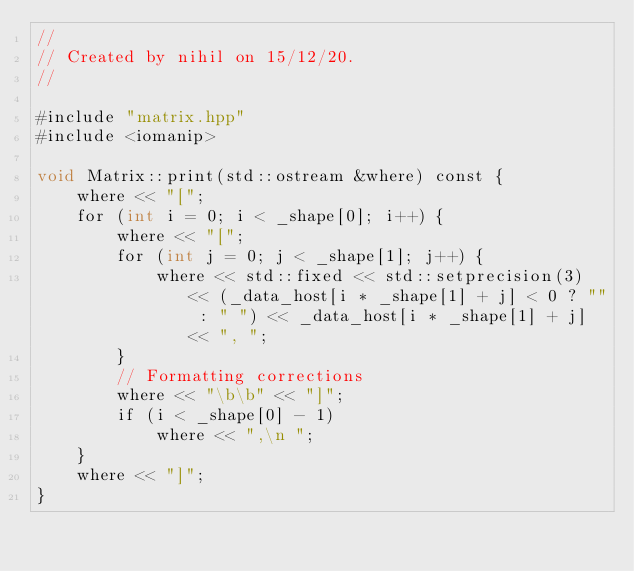<code> <loc_0><loc_0><loc_500><loc_500><_Cuda_>//
// Created by nihil on 15/12/20.
//

#include "matrix.hpp"
#include <iomanip>

void Matrix::print(std::ostream &where) const {
    where << "[";
    for (int i = 0; i < _shape[0]; i++) {
        where << "[";
        for (int j = 0; j < _shape[1]; j++) {
            where << std::fixed << std::setprecision(3) << (_data_host[i * _shape[1] + j] < 0 ? "" : " ") << _data_host[i * _shape[1] + j] << ", ";
        }
        // Formatting corrections
        where << "\b\b" << "]";
        if (i < _shape[0] - 1)
            where << ",\n ";
    }
    where << "]";
}</code> 